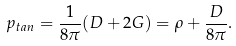<formula> <loc_0><loc_0><loc_500><loc_500>p _ { t a n } = \frac { 1 } { 8 \pi } ( D + 2 G ) = \rho + \frac { D } { 8 \pi } .</formula> 